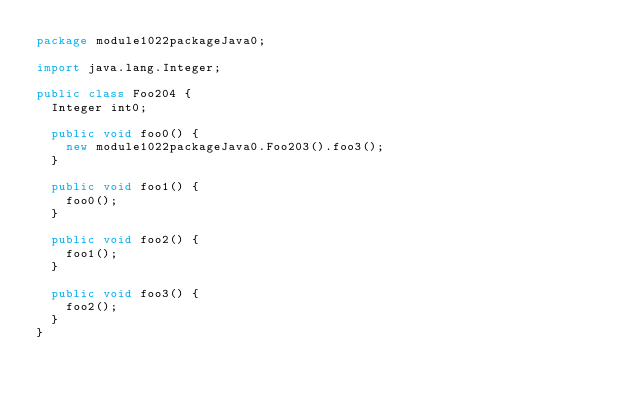Convert code to text. <code><loc_0><loc_0><loc_500><loc_500><_Java_>package module1022packageJava0;

import java.lang.Integer;

public class Foo204 {
  Integer int0;

  public void foo0() {
    new module1022packageJava0.Foo203().foo3();
  }

  public void foo1() {
    foo0();
  }

  public void foo2() {
    foo1();
  }

  public void foo3() {
    foo2();
  }
}
</code> 